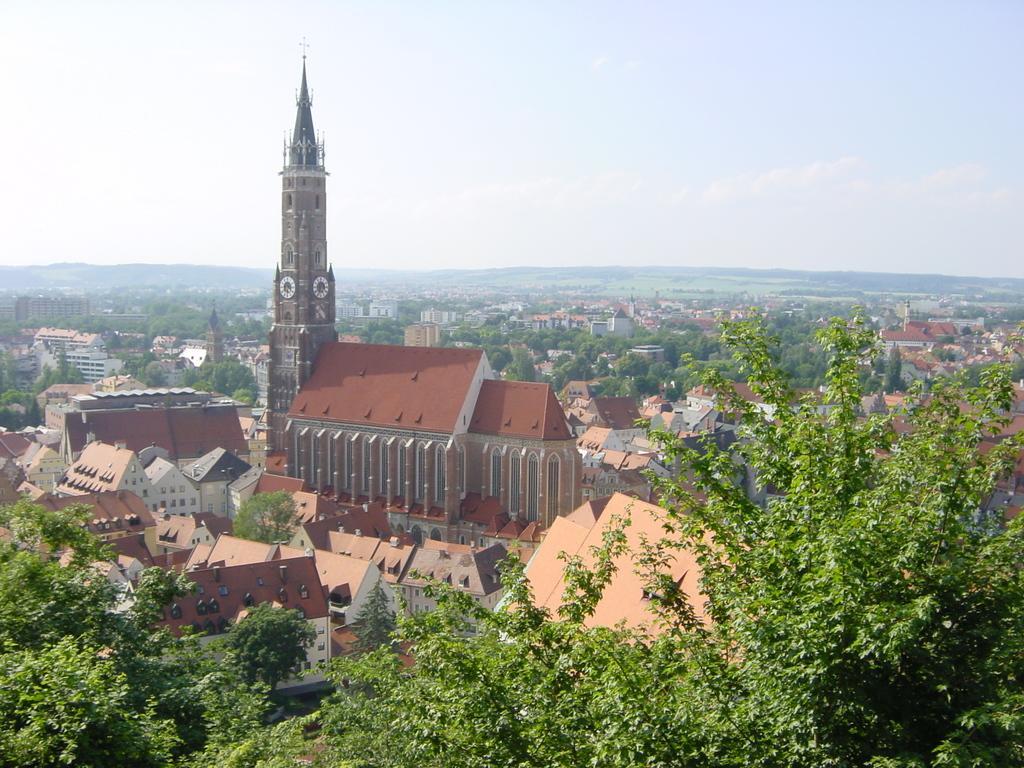Could you give a brief overview of what you see in this image? In this image we can see some houses with roof and pillars. We can also see some clock tower. On the backside we can see a group of trees, houses, hills and the sky which looks cloudy. 